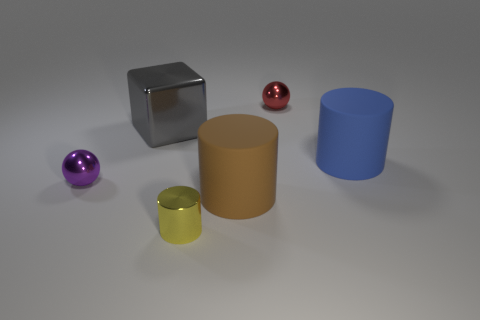What is the material of the tiny yellow cylinder? The material of the small yellow cylinder appears to be a reflective metal, evidenced by the way light is bouncing off its surface, creating highlights and casting a shadow consistent with metallic objects. 